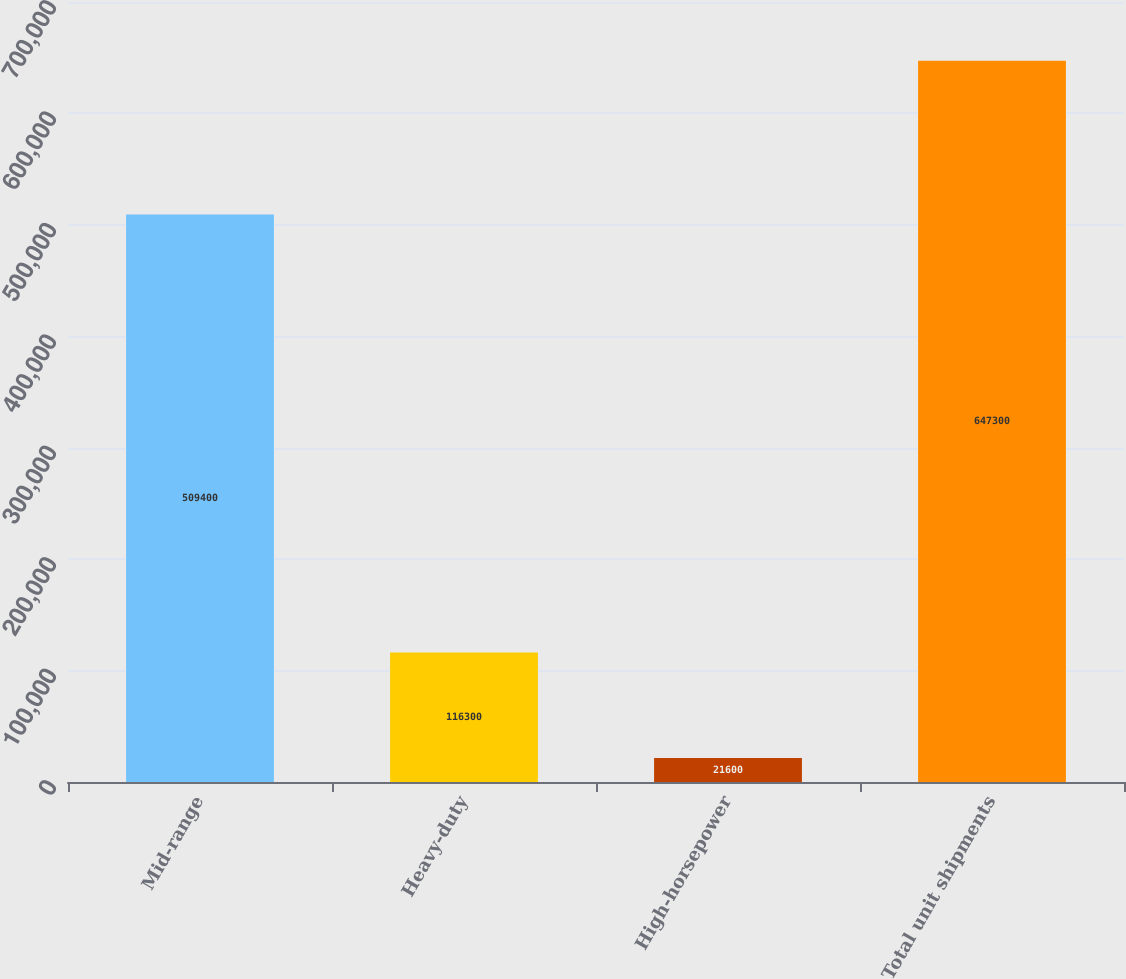Convert chart. <chart><loc_0><loc_0><loc_500><loc_500><bar_chart><fcel>Mid-range<fcel>Heavy-duty<fcel>High-horsepower<fcel>Total unit shipments<nl><fcel>509400<fcel>116300<fcel>21600<fcel>647300<nl></chart> 